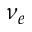Convert formula to latex. <formula><loc_0><loc_0><loc_500><loc_500>\nu _ { e }</formula> 